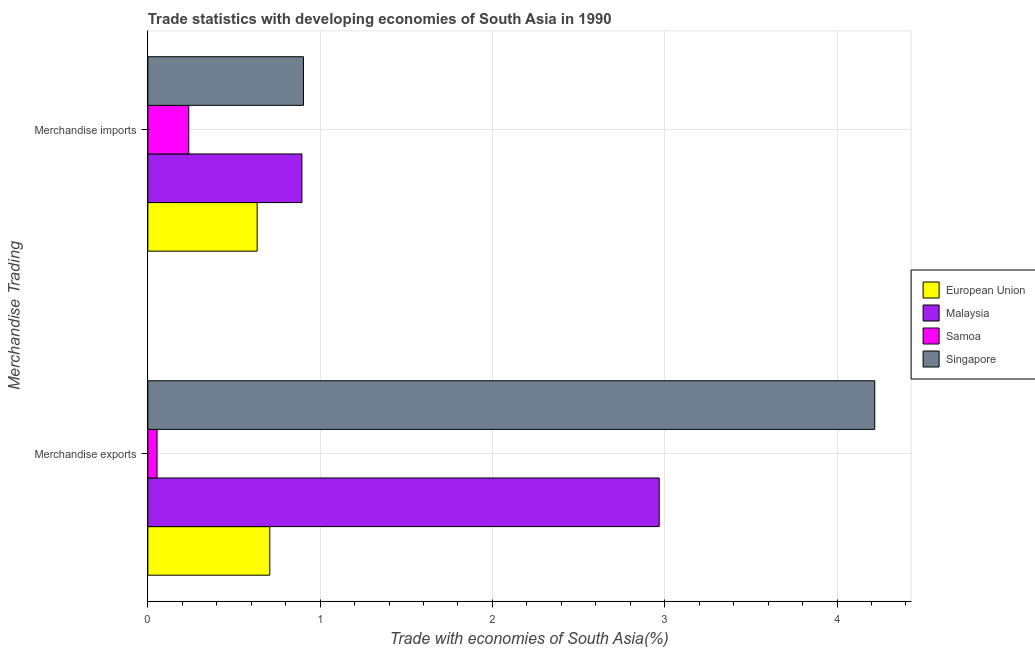Are the number of bars per tick equal to the number of legend labels?
Make the answer very short. Yes. What is the label of the 1st group of bars from the top?
Provide a succinct answer. Merchandise imports. What is the merchandise imports in Singapore?
Your answer should be very brief. 0.9. Across all countries, what is the maximum merchandise exports?
Ensure brevity in your answer.  4.22. Across all countries, what is the minimum merchandise imports?
Offer a terse response. 0.24. In which country was the merchandise imports maximum?
Give a very brief answer. Singapore. In which country was the merchandise imports minimum?
Your response must be concise. Samoa. What is the total merchandise exports in the graph?
Make the answer very short. 7.95. What is the difference between the merchandise imports in European Union and that in Samoa?
Ensure brevity in your answer.  0.4. What is the difference between the merchandise exports in Singapore and the merchandise imports in Samoa?
Provide a succinct answer. 3.98. What is the average merchandise imports per country?
Your answer should be very brief. 0.67. What is the difference between the merchandise imports and merchandise exports in Samoa?
Keep it short and to the point. 0.18. In how many countries, is the merchandise imports greater than 1.2 %?
Your answer should be very brief. 0. What is the ratio of the merchandise imports in Singapore to that in Malaysia?
Ensure brevity in your answer.  1.01. In how many countries, is the merchandise exports greater than the average merchandise exports taken over all countries?
Provide a succinct answer. 2. What does the 1st bar from the top in Merchandise exports represents?
Your answer should be compact. Singapore. What does the 3rd bar from the bottom in Merchandise imports represents?
Provide a short and direct response. Samoa. Are all the bars in the graph horizontal?
Ensure brevity in your answer.  Yes. How many countries are there in the graph?
Provide a short and direct response. 4. What is the difference between two consecutive major ticks on the X-axis?
Ensure brevity in your answer.  1. Does the graph contain any zero values?
Make the answer very short. No. Does the graph contain grids?
Your answer should be very brief. Yes. How many legend labels are there?
Your response must be concise. 4. How are the legend labels stacked?
Offer a very short reply. Vertical. What is the title of the graph?
Give a very brief answer. Trade statistics with developing economies of South Asia in 1990. What is the label or title of the X-axis?
Ensure brevity in your answer.  Trade with economies of South Asia(%). What is the label or title of the Y-axis?
Your answer should be very brief. Merchandise Trading. What is the Trade with economies of South Asia(%) in European Union in Merchandise exports?
Your answer should be compact. 0.71. What is the Trade with economies of South Asia(%) of Malaysia in Merchandise exports?
Provide a succinct answer. 2.97. What is the Trade with economies of South Asia(%) in Samoa in Merchandise exports?
Your answer should be compact. 0.05. What is the Trade with economies of South Asia(%) of Singapore in Merchandise exports?
Offer a terse response. 4.22. What is the Trade with economies of South Asia(%) in European Union in Merchandise imports?
Offer a very short reply. 0.63. What is the Trade with economies of South Asia(%) in Malaysia in Merchandise imports?
Your answer should be compact. 0.89. What is the Trade with economies of South Asia(%) of Samoa in Merchandise imports?
Provide a short and direct response. 0.24. What is the Trade with economies of South Asia(%) in Singapore in Merchandise imports?
Your answer should be compact. 0.9. Across all Merchandise Trading, what is the maximum Trade with economies of South Asia(%) of European Union?
Give a very brief answer. 0.71. Across all Merchandise Trading, what is the maximum Trade with economies of South Asia(%) in Malaysia?
Provide a succinct answer. 2.97. Across all Merchandise Trading, what is the maximum Trade with economies of South Asia(%) in Samoa?
Ensure brevity in your answer.  0.24. Across all Merchandise Trading, what is the maximum Trade with economies of South Asia(%) in Singapore?
Provide a short and direct response. 4.22. Across all Merchandise Trading, what is the minimum Trade with economies of South Asia(%) in European Union?
Offer a terse response. 0.63. Across all Merchandise Trading, what is the minimum Trade with economies of South Asia(%) of Malaysia?
Offer a very short reply. 0.89. Across all Merchandise Trading, what is the minimum Trade with economies of South Asia(%) in Samoa?
Provide a succinct answer. 0.05. Across all Merchandise Trading, what is the minimum Trade with economies of South Asia(%) in Singapore?
Ensure brevity in your answer.  0.9. What is the total Trade with economies of South Asia(%) of European Union in the graph?
Your response must be concise. 1.34. What is the total Trade with economies of South Asia(%) in Malaysia in the graph?
Offer a terse response. 3.86. What is the total Trade with economies of South Asia(%) of Samoa in the graph?
Provide a succinct answer. 0.29. What is the total Trade with economies of South Asia(%) in Singapore in the graph?
Offer a very short reply. 5.12. What is the difference between the Trade with economies of South Asia(%) in European Union in Merchandise exports and that in Merchandise imports?
Keep it short and to the point. 0.07. What is the difference between the Trade with economies of South Asia(%) of Malaysia in Merchandise exports and that in Merchandise imports?
Provide a succinct answer. 2.07. What is the difference between the Trade with economies of South Asia(%) in Samoa in Merchandise exports and that in Merchandise imports?
Provide a short and direct response. -0.18. What is the difference between the Trade with economies of South Asia(%) of Singapore in Merchandise exports and that in Merchandise imports?
Offer a terse response. 3.32. What is the difference between the Trade with economies of South Asia(%) of European Union in Merchandise exports and the Trade with economies of South Asia(%) of Malaysia in Merchandise imports?
Your answer should be compact. -0.19. What is the difference between the Trade with economies of South Asia(%) in European Union in Merchandise exports and the Trade with economies of South Asia(%) in Samoa in Merchandise imports?
Give a very brief answer. 0.47. What is the difference between the Trade with economies of South Asia(%) in European Union in Merchandise exports and the Trade with economies of South Asia(%) in Singapore in Merchandise imports?
Make the answer very short. -0.2. What is the difference between the Trade with economies of South Asia(%) of Malaysia in Merchandise exports and the Trade with economies of South Asia(%) of Samoa in Merchandise imports?
Keep it short and to the point. 2.73. What is the difference between the Trade with economies of South Asia(%) of Malaysia in Merchandise exports and the Trade with economies of South Asia(%) of Singapore in Merchandise imports?
Ensure brevity in your answer.  2.06. What is the difference between the Trade with economies of South Asia(%) of Samoa in Merchandise exports and the Trade with economies of South Asia(%) of Singapore in Merchandise imports?
Give a very brief answer. -0.85. What is the average Trade with economies of South Asia(%) in European Union per Merchandise Trading?
Your answer should be very brief. 0.67. What is the average Trade with economies of South Asia(%) of Malaysia per Merchandise Trading?
Keep it short and to the point. 1.93. What is the average Trade with economies of South Asia(%) of Samoa per Merchandise Trading?
Provide a short and direct response. 0.15. What is the average Trade with economies of South Asia(%) in Singapore per Merchandise Trading?
Offer a terse response. 2.56. What is the difference between the Trade with economies of South Asia(%) of European Union and Trade with economies of South Asia(%) of Malaysia in Merchandise exports?
Give a very brief answer. -2.26. What is the difference between the Trade with economies of South Asia(%) of European Union and Trade with economies of South Asia(%) of Samoa in Merchandise exports?
Keep it short and to the point. 0.65. What is the difference between the Trade with economies of South Asia(%) in European Union and Trade with economies of South Asia(%) in Singapore in Merchandise exports?
Offer a very short reply. -3.51. What is the difference between the Trade with economies of South Asia(%) in Malaysia and Trade with economies of South Asia(%) in Samoa in Merchandise exports?
Provide a succinct answer. 2.91. What is the difference between the Trade with economies of South Asia(%) of Malaysia and Trade with economies of South Asia(%) of Singapore in Merchandise exports?
Offer a very short reply. -1.25. What is the difference between the Trade with economies of South Asia(%) in Samoa and Trade with economies of South Asia(%) in Singapore in Merchandise exports?
Make the answer very short. -4.17. What is the difference between the Trade with economies of South Asia(%) in European Union and Trade with economies of South Asia(%) in Malaysia in Merchandise imports?
Your answer should be compact. -0.26. What is the difference between the Trade with economies of South Asia(%) in European Union and Trade with economies of South Asia(%) in Samoa in Merchandise imports?
Make the answer very short. 0.4. What is the difference between the Trade with economies of South Asia(%) of European Union and Trade with economies of South Asia(%) of Singapore in Merchandise imports?
Your answer should be compact. -0.27. What is the difference between the Trade with economies of South Asia(%) of Malaysia and Trade with economies of South Asia(%) of Samoa in Merchandise imports?
Make the answer very short. 0.66. What is the difference between the Trade with economies of South Asia(%) in Malaysia and Trade with economies of South Asia(%) in Singapore in Merchandise imports?
Your response must be concise. -0.01. What is the difference between the Trade with economies of South Asia(%) in Samoa and Trade with economies of South Asia(%) in Singapore in Merchandise imports?
Make the answer very short. -0.67. What is the ratio of the Trade with economies of South Asia(%) of European Union in Merchandise exports to that in Merchandise imports?
Provide a short and direct response. 1.12. What is the ratio of the Trade with economies of South Asia(%) of Malaysia in Merchandise exports to that in Merchandise imports?
Make the answer very short. 3.32. What is the ratio of the Trade with economies of South Asia(%) in Samoa in Merchandise exports to that in Merchandise imports?
Ensure brevity in your answer.  0.22. What is the ratio of the Trade with economies of South Asia(%) in Singapore in Merchandise exports to that in Merchandise imports?
Give a very brief answer. 4.67. What is the difference between the highest and the second highest Trade with economies of South Asia(%) of European Union?
Provide a short and direct response. 0.07. What is the difference between the highest and the second highest Trade with economies of South Asia(%) of Malaysia?
Give a very brief answer. 2.07. What is the difference between the highest and the second highest Trade with economies of South Asia(%) of Samoa?
Your answer should be compact. 0.18. What is the difference between the highest and the second highest Trade with economies of South Asia(%) of Singapore?
Your answer should be very brief. 3.32. What is the difference between the highest and the lowest Trade with economies of South Asia(%) in European Union?
Offer a very short reply. 0.07. What is the difference between the highest and the lowest Trade with economies of South Asia(%) in Malaysia?
Ensure brevity in your answer.  2.07. What is the difference between the highest and the lowest Trade with economies of South Asia(%) in Samoa?
Ensure brevity in your answer.  0.18. What is the difference between the highest and the lowest Trade with economies of South Asia(%) in Singapore?
Give a very brief answer. 3.32. 